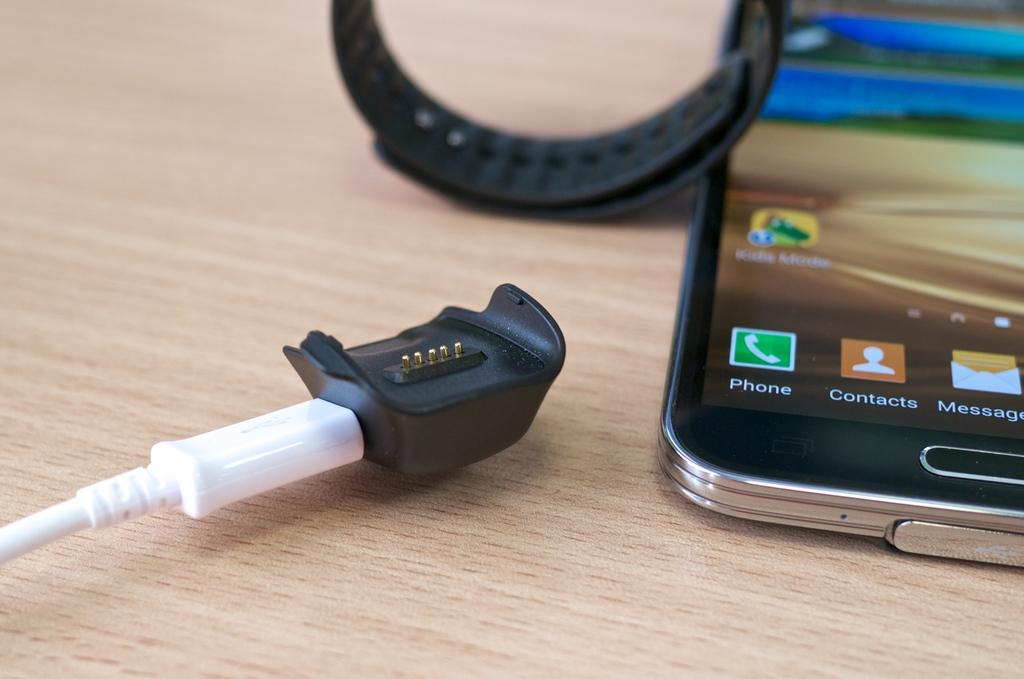<image>
Write a terse but informative summary of the picture. A white charger is attached to a small, black plastic piece, beside the bottom of a smart phone where you can see the Kid Mode app. 